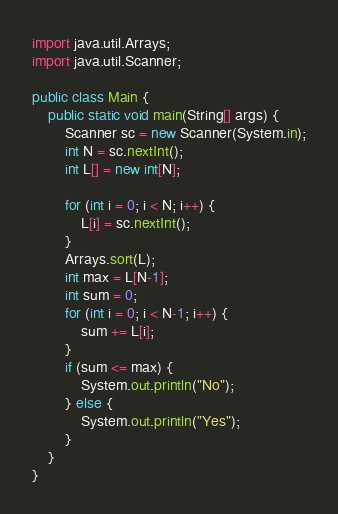Convert code to text. <code><loc_0><loc_0><loc_500><loc_500><_Java_>import java.util.Arrays;
import java.util.Scanner;

public class Main {
	public static void main(String[] args) {
		Scanner sc = new Scanner(System.in);
		int N = sc.nextInt();
		int L[] = new int[N];

		for (int i = 0; i < N; i++) {
			L[i] = sc.nextInt();
		}
		Arrays.sort(L);
		int max = L[N-1];
		int sum = 0;
		for (int i = 0; i < N-1; i++) {
			sum += L[i];
		}
		if (sum <= max) {
			System.out.println("No");
		} else {
			System.out.println("Yes");
		}
	}
}
</code> 